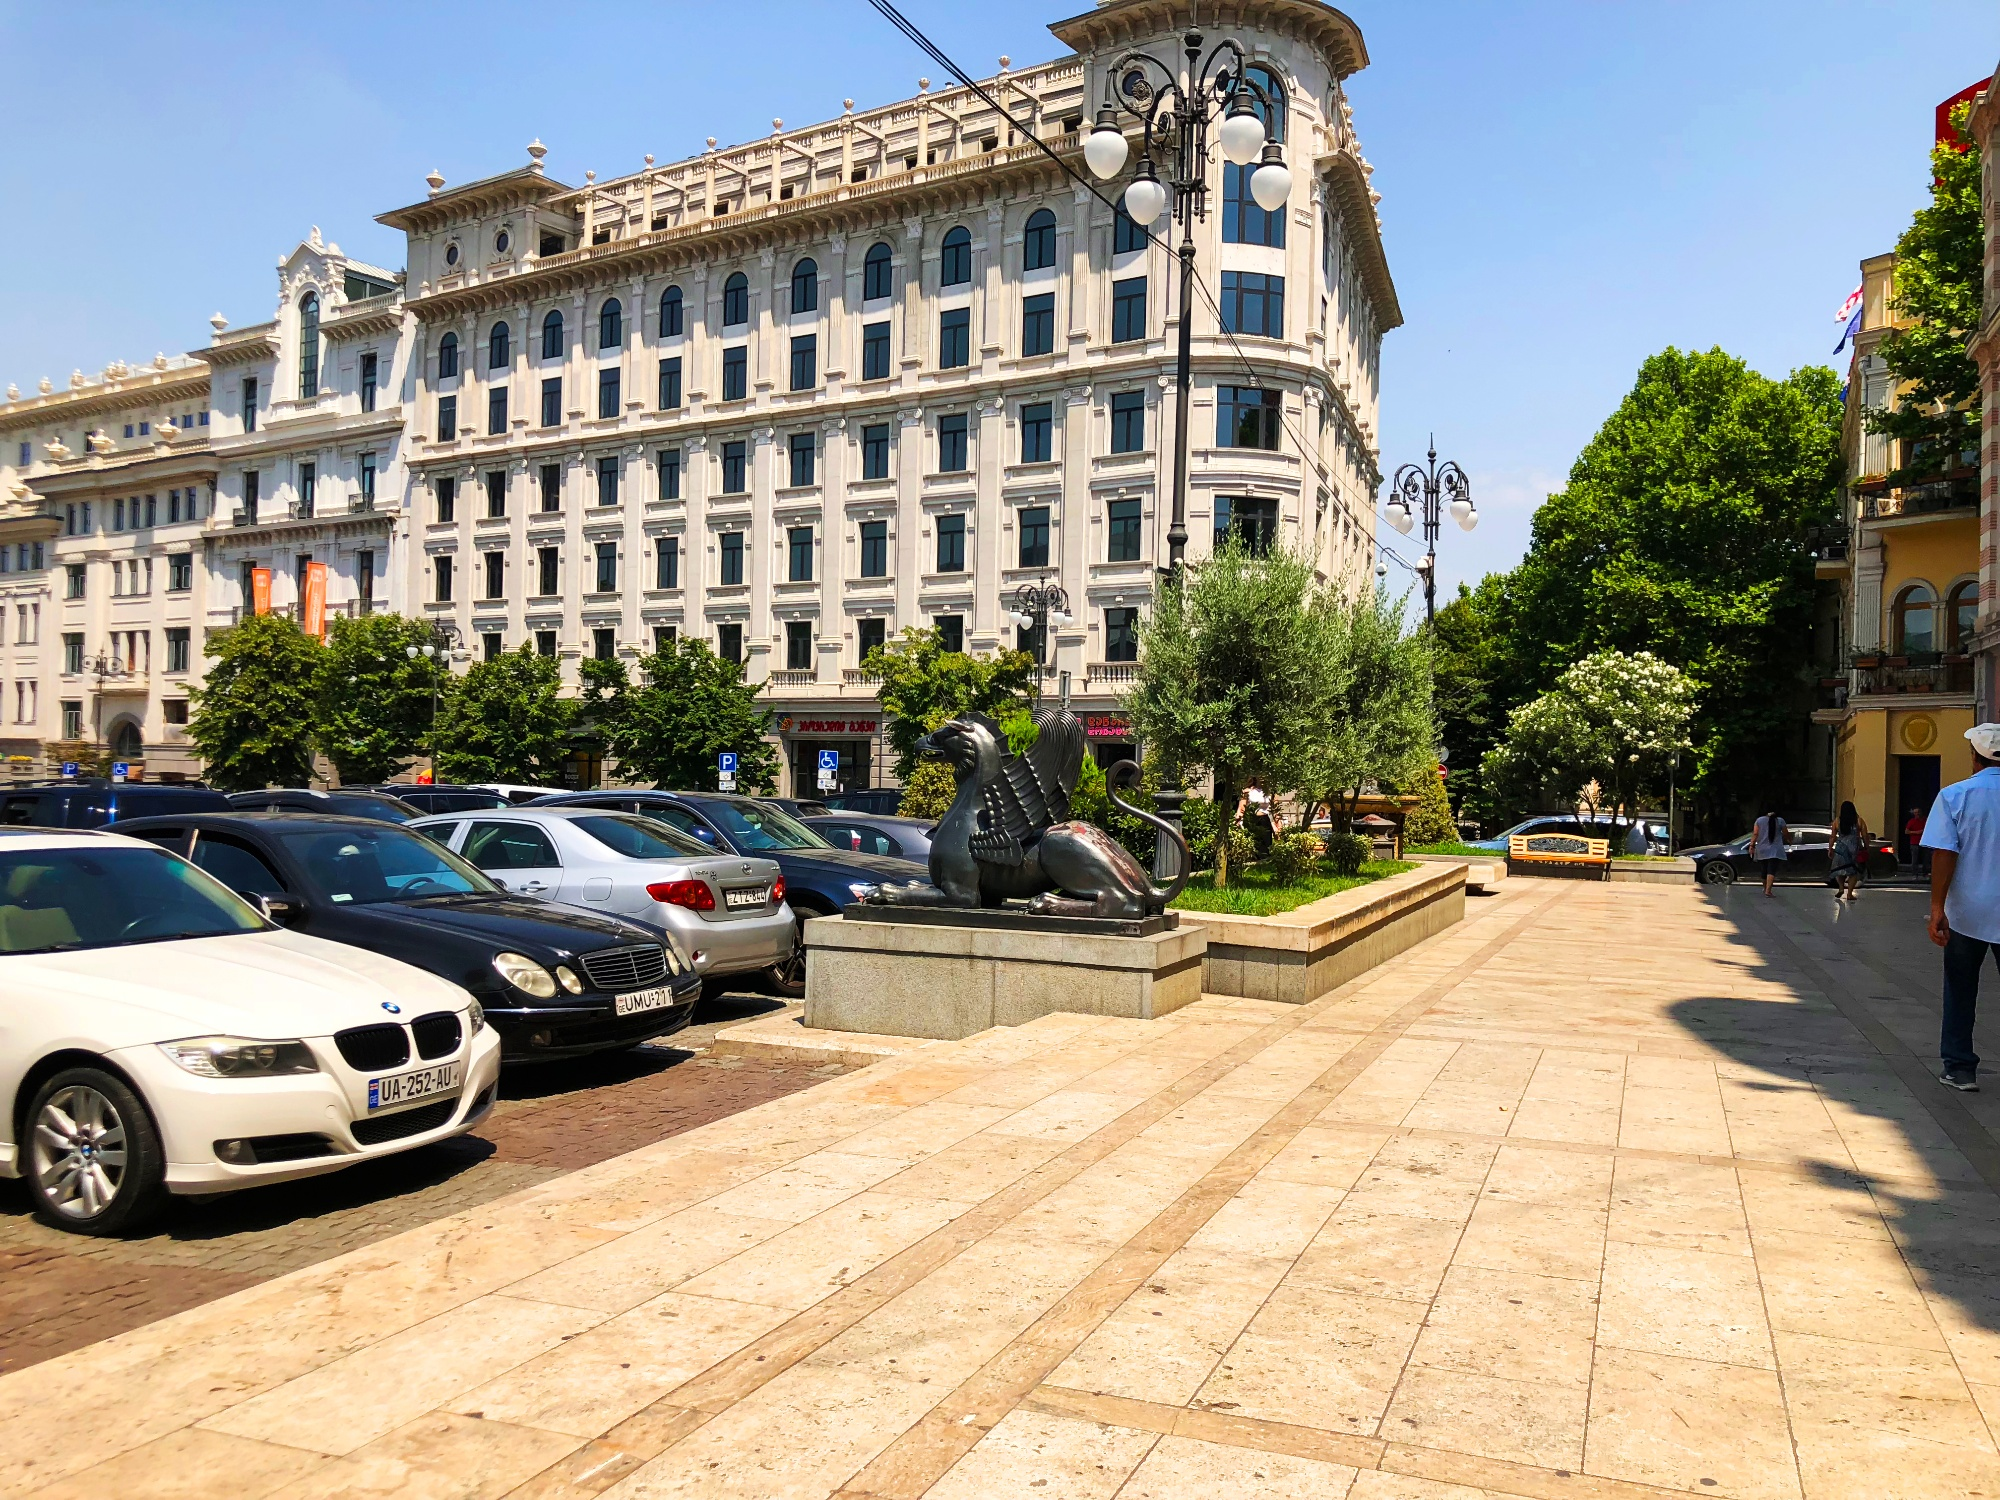What kind of atmosphere does the image suggest about this city space? The image emanates an atmosphere of vitality and elegance. The well-manicured trees and the clean, wide pedestrian walkways suggest a city that values its appearance and heritage. The interaction of people and vehicles implies a bustling environment, yet there's also a sense of order and tranquility. It's a space where daily life unfolds against a backdrop of historical beauty, offering a blend of peaceful coexistence and urban dynamism. 